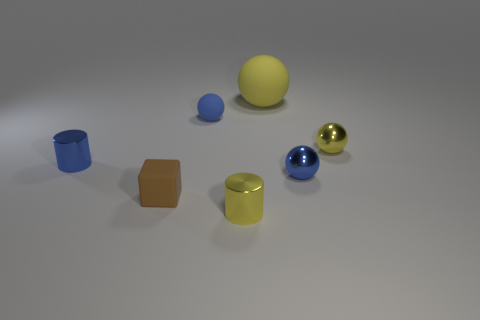Subtract all large yellow matte spheres. How many spheres are left? 3 Subtract all yellow balls. How many balls are left? 2 Subtract 1 spheres. How many spheres are left? 3 Subtract all balls. How many objects are left? 3 Add 1 small blue shiny spheres. How many objects exist? 8 Subtract all red spheres. How many green blocks are left? 0 Subtract 0 purple cubes. How many objects are left? 7 Subtract all green balls. Subtract all red cubes. How many balls are left? 4 Subtract all yellow metal cylinders. Subtract all blocks. How many objects are left? 5 Add 7 small brown rubber cubes. How many small brown rubber cubes are left? 8 